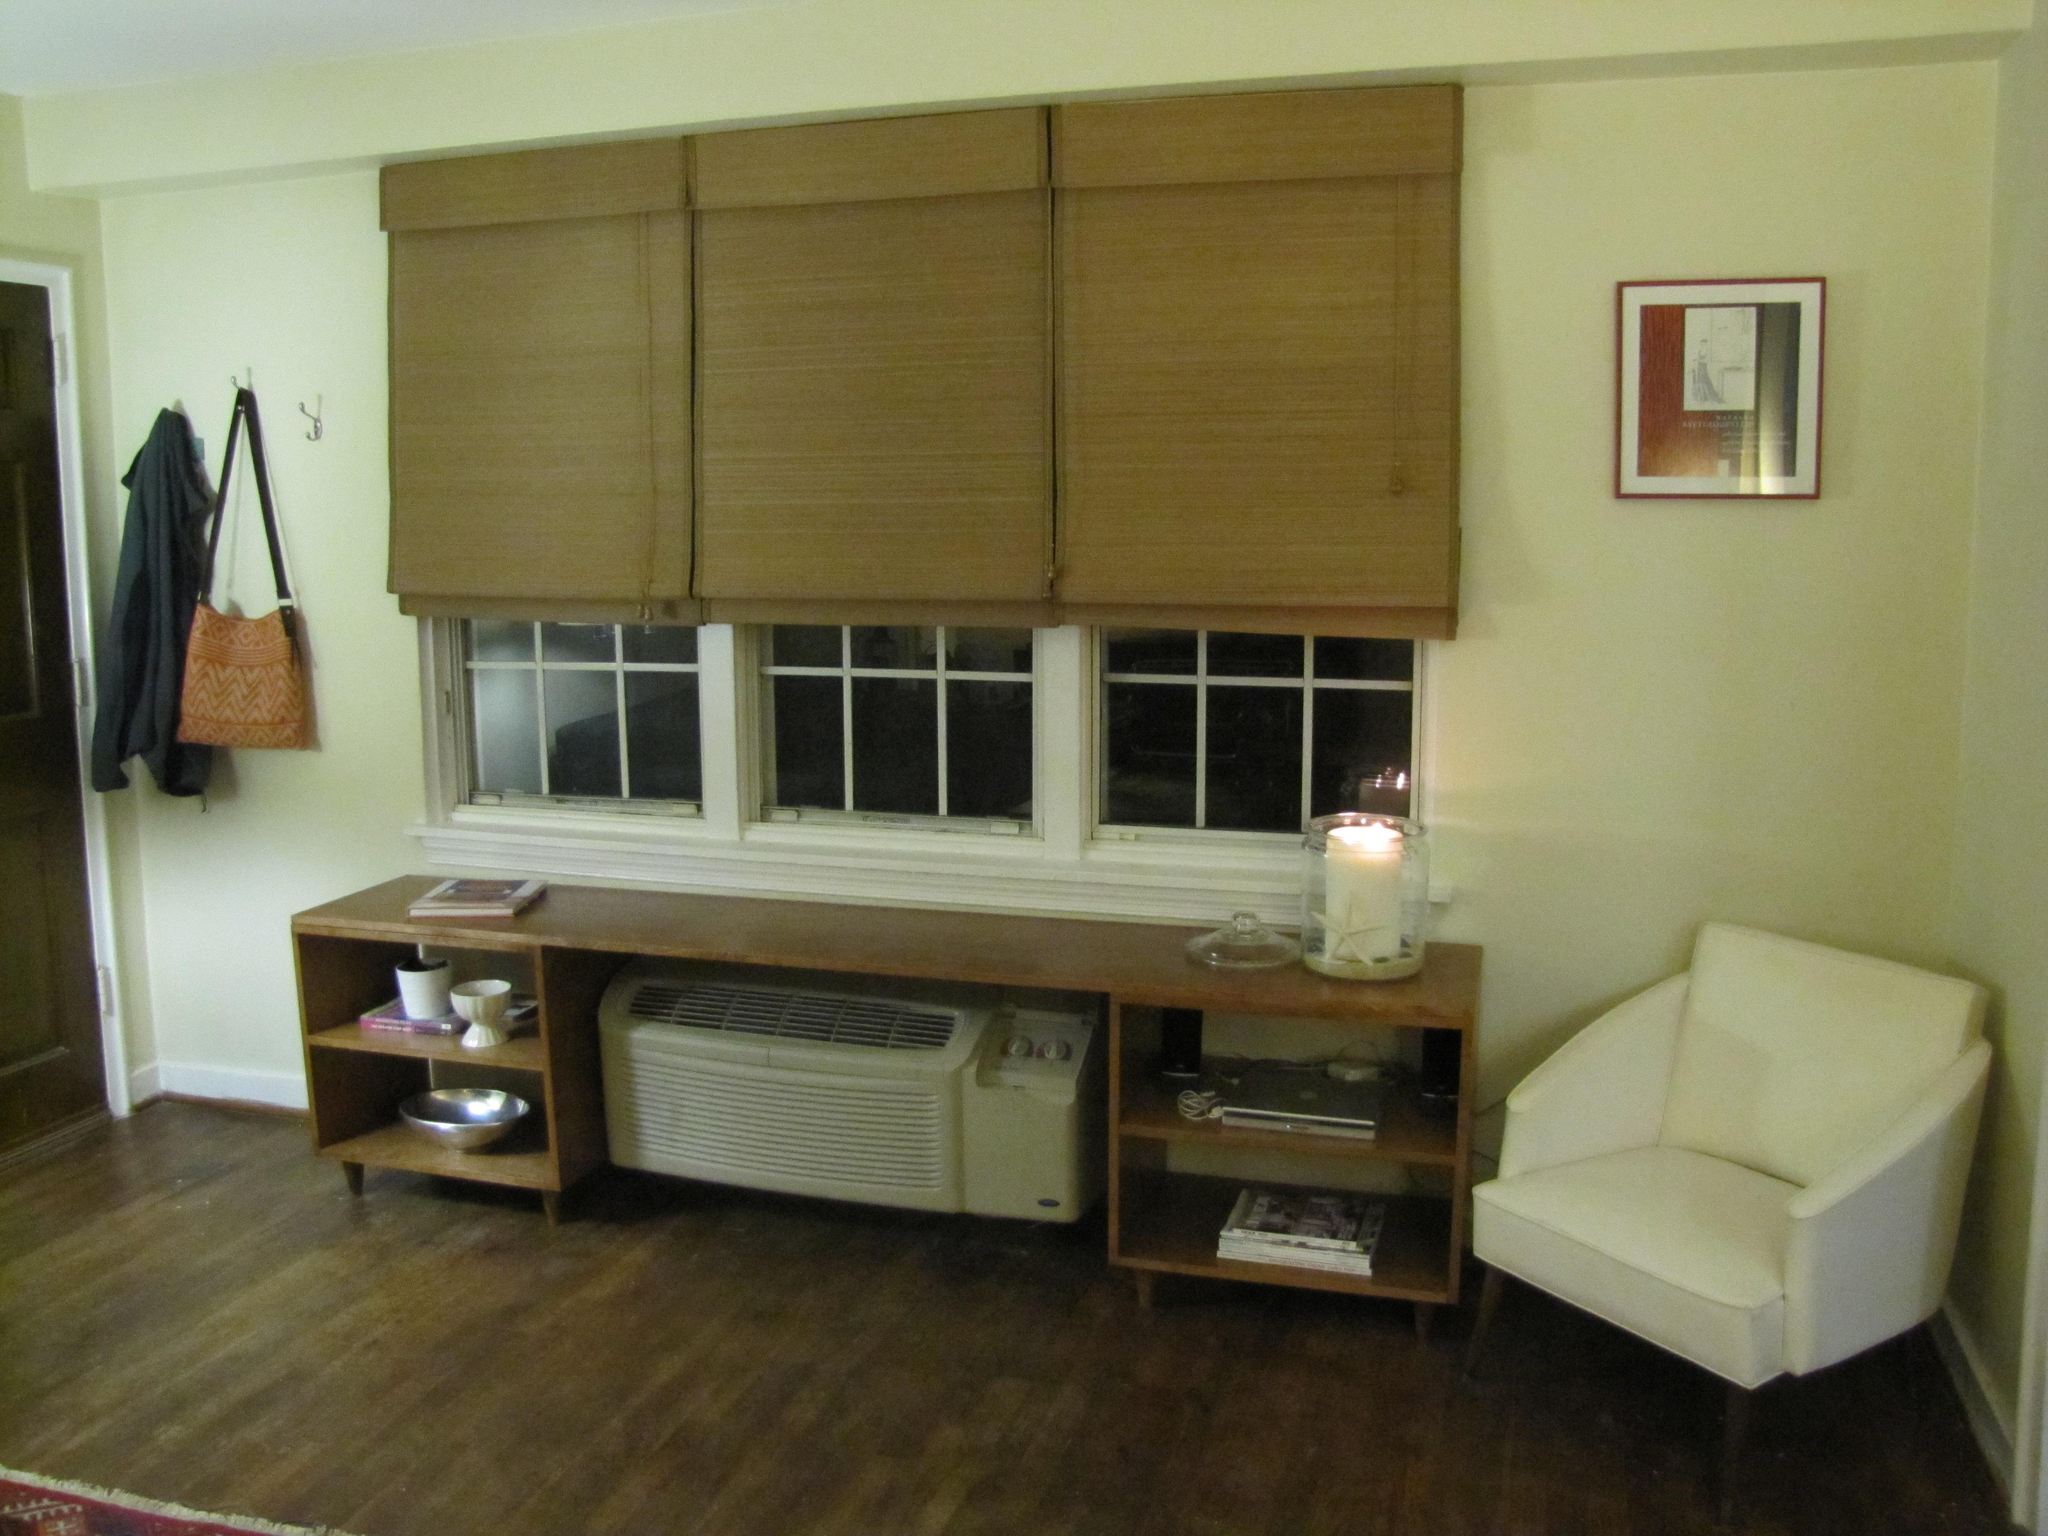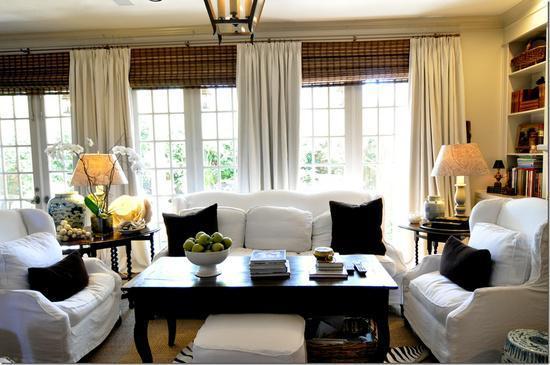The first image is the image on the left, the second image is the image on the right. Considering the images on both sides, is "There are six blinds." valid? Answer yes or no. Yes. The first image is the image on the left, the second image is the image on the right. Given the left and right images, does the statement "At least one shade is all the way closed." hold true? Answer yes or no. No. 